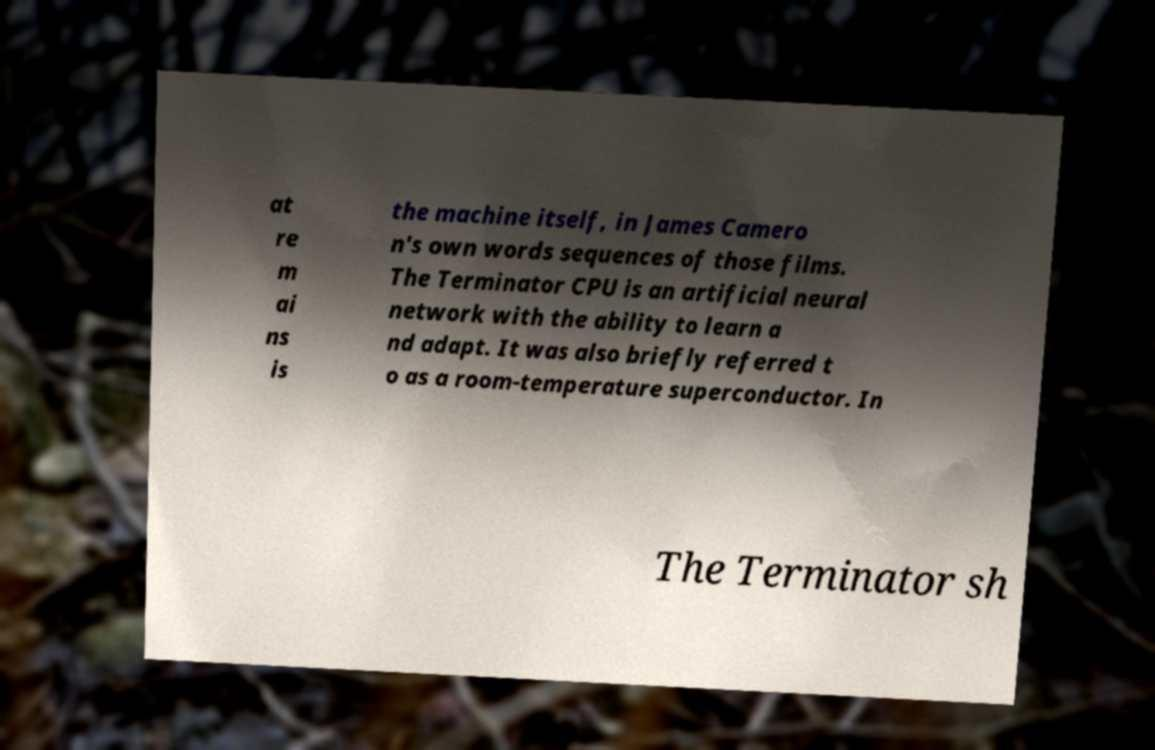Please identify and transcribe the text found in this image. at re m ai ns is the machine itself, in James Camero n's own words sequences of those films. The Terminator CPU is an artificial neural network with the ability to learn a nd adapt. It was also briefly referred t o as a room-temperature superconductor. In The Terminator sh 